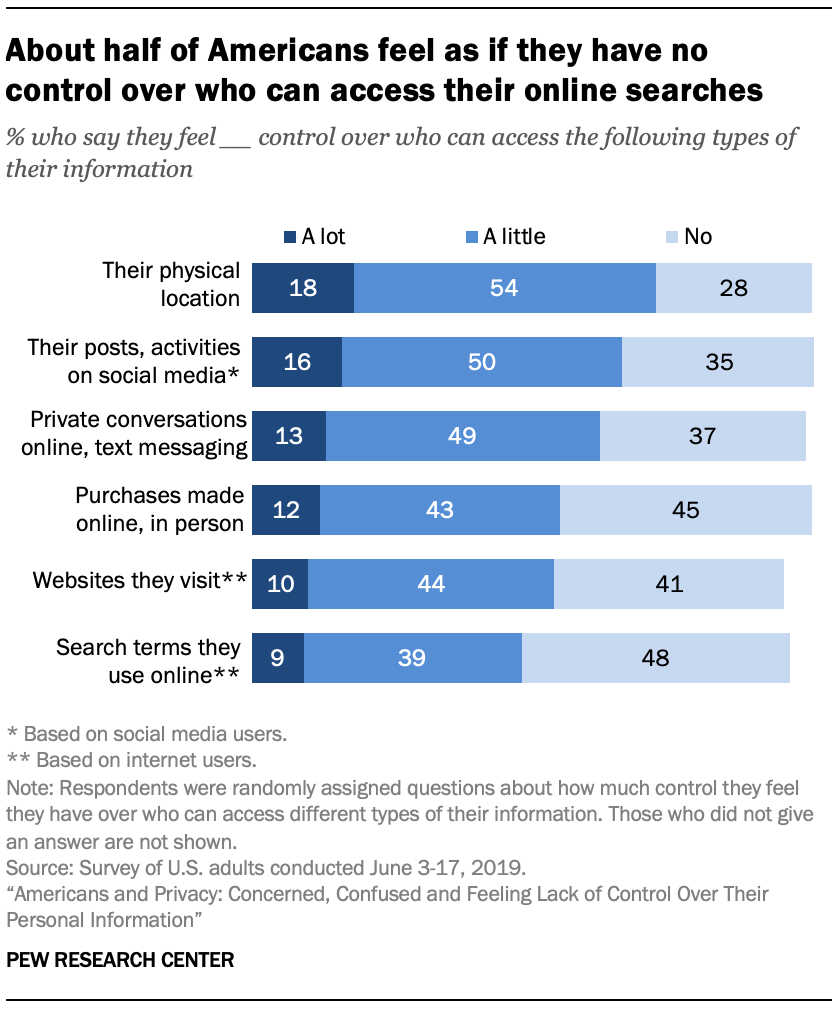Mention a couple of crucial points in this snapshot. Of the sections, four do not have any options that are over 35%. According to data, a significant percentage of people choose 'no' when presented with websites they visit, specifically 41.. 